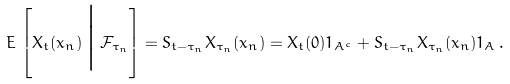<formula> <loc_0><loc_0><loc_500><loc_500>E \, \left [ X _ { t } ( x _ { n } ) \, \Big | \, \mathcal { F } _ { \tau _ { n } } \right ] = S _ { t - \tau _ { n } } X _ { \tau _ { n } } ( x _ { n } ) = X _ { t } ( 0 ) 1 _ { A ^ { c } } + S _ { t - \tau _ { n } } X _ { \tau _ { n } } ( x _ { n } ) 1 _ { A \, } .</formula> 